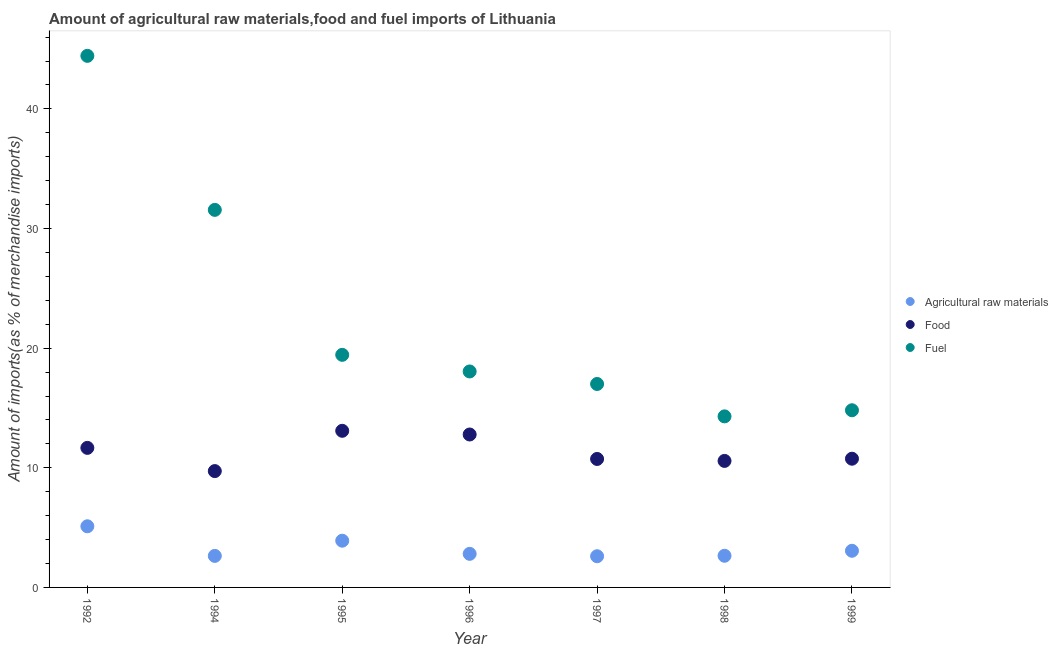How many different coloured dotlines are there?
Provide a succinct answer. 3. Is the number of dotlines equal to the number of legend labels?
Provide a short and direct response. Yes. What is the percentage of raw materials imports in 1998?
Offer a terse response. 2.65. Across all years, what is the maximum percentage of food imports?
Provide a succinct answer. 13.09. Across all years, what is the minimum percentage of food imports?
Provide a succinct answer. 9.72. In which year was the percentage of food imports maximum?
Offer a terse response. 1995. What is the total percentage of food imports in the graph?
Keep it short and to the point. 79.33. What is the difference between the percentage of fuel imports in 1992 and that in 1994?
Make the answer very short. 12.87. What is the difference between the percentage of food imports in 1996 and the percentage of raw materials imports in 1992?
Offer a terse response. 7.67. What is the average percentage of raw materials imports per year?
Give a very brief answer. 3.25. In the year 1996, what is the difference between the percentage of raw materials imports and percentage of food imports?
Provide a short and direct response. -9.98. What is the ratio of the percentage of food imports in 1997 to that in 1999?
Provide a short and direct response. 1. What is the difference between the highest and the second highest percentage of raw materials imports?
Give a very brief answer. 1.2. What is the difference between the highest and the lowest percentage of fuel imports?
Provide a succinct answer. 30.13. In how many years, is the percentage of fuel imports greater than the average percentage of fuel imports taken over all years?
Offer a terse response. 2. Is the sum of the percentage of food imports in 1996 and 1998 greater than the maximum percentage of fuel imports across all years?
Make the answer very short. No. Is it the case that in every year, the sum of the percentage of raw materials imports and percentage of food imports is greater than the percentage of fuel imports?
Your answer should be compact. No. Does the percentage of raw materials imports monotonically increase over the years?
Your answer should be compact. No. Is the percentage of raw materials imports strictly less than the percentage of food imports over the years?
Make the answer very short. Yes. How many dotlines are there?
Your response must be concise. 3. What is the difference between two consecutive major ticks on the Y-axis?
Offer a terse response. 10. Does the graph contain any zero values?
Give a very brief answer. No. Does the graph contain grids?
Your response must be concise. No. How many legend labels are there?
Your answer should be very brief. 3. What is the title of the graph?
Offer a very short reply. Amount of agricultural raw materials,food and fuel imports of Lithuania. What is the label or title of the X-axis?
Give a very brief answer. Year. What is the label or title of the Y-axis?
Offer a terse response. Amount of imports(as % of merchandise imports). What is the Amount of imports(as % of merchandise imports) in Agricultural raw materials in 1992?
Your answer should be very brief. 5.11. What is the Amount of imports(as % of merchandise imports) in Food in 1992?
Keep it short and to the point. 11.66. What is the Amount of imports(as % of merchandise imports) in Fuel in 1992?
Keep it short and to the point. 44.43. What is the Amount of imports(as % of merchandise imports) in Agricultural raw materials in 1994?
Provide a short and direct response. 2.64. What is the Amount of imports(as % of merchandise imports) in Food in 1994?
Keep it short and to the point. 9.72. What is the Amount of imports(as % of merchandise imports) of Fuel in 1994?
Keep it short and to the point. 31.56. What is the Amount of imports(as % of merchandise imports) of Agricultural raw materials in 1995?
Give a very brief answer. 3.91. What is the Amount of imports(as % of merchandise imports) in Food in 1995?
Keep it short and to the point. 13.09. What is the Amount of imports(as % of merchandise imports) of Fuel in 1995?
Provide a short and direct response. 19.44. What is the Amount of imports(as % of merchandise imports) of Agricultural raw materials in 1996?
Offer a terse response. 2.81. What is the Amount of imports(as % of merchandise imports) of Food in 1996?
Make the answer very short. 12.78. What is the Amount of imports(as % of merchandise imports) in Fuel in 1996?
Provide a succinct answer. 18.05. What is the Amount of imports(as % of merchandise imports) in Agricultural raw materials in 1997?
Keep it short and to the point. 2.61. What is the Amount of imports(as % of merchandise imports) of Food in 1997?
Keep it short and to the point. 10.74. What is the Amount of imports(as % of merchandise imports) of Fuel in 1997?
Offer a very short reply. 17. What is the Amount of imports(as % of merchandise imports) of Agricultural raw materials in 1998?
Keep it short and to the point. 2.65. What is the Amount of imports(as % of merchandise imports) in Food in 1998?
Offer a terse response. 10.57. What is the Amount of imports(as % of merchandise imports) of Fuel in 1998?
Give a very brief answer. 14.3. What is the Amount of imports(as % of merchandise imports) of Agricultural raw materials in 1999?
Provide a succinct answer. 3.06. What is the Amount of imports(as % of merchandise imports) of Food in 1999?
Make the answer very short. 10.76. What is the Amount of imports(as % of merchandise imports) in Fuel in 1999?
Offer a terse response. 14.81. Across all years, what is the maximum Amount of imports(as % of merchandise imports) of Agricultural raw materials?
Ensure brevity in your answer.  5.11. Across all years, what is the maximum Amount of imports(as % of merchandise imports) of Food?
Keep it short and to the point. 13.09. Across all years, what is the maximum Amount of imports(as % of merchandise imports) of Fuel?
Your answer should be very brief. 44.43. Across all years, what is the minimum Amount of imports(as % of merchandise imports) in Agricultural raw materials?
Make the answer very short. 2.61. Across all years, what is the minimum Amount of imports(as % of merchandise imports) of Food?
Offer a very short reply. 9.72. Across all years, what is the minimum Amount of imports(as % of merchandise imports) of Fuel?
Keep it short and to the point. 14.3. What is the total Amount of imports(as % of merchandise imports) of Agricultural raw materials in the graph?
Your answer should be very brief. 22.78. What is the total Amount of imports(as % of merchandise imports) of Food in the graph?
Offer a very short reply. 79.33. What is the total Amount of imports(as % of merchandise imports) in Fuel in the graph?
Provide a short and direct response. 159.59. What is the difference between the Amount of imports(as % of merchandise imports) in Agricultural raw materials in 1992 and that in 1994?
Offer a terse response. 2.48. What is the difference between the Amount of imports(as % of merchandise imports) of Food in 1992 and that in 1994?
Ensure brevity in your answer.  1.94. What is the difference between the Amount of imports(as % of merchandise imports) of Fuel in 1992 and that in 1994?
Make the answer very short. 12.87. What is the difference between the Amount of imports(as % of merchandise imports) in Agricultural raw materials in 1992 and that in 1995?
Offer a terse response. 1.2. What is the difference between the Amount of imports(as % of merchandise imports) of Food in 1992 and that in 1995?
Your answer should be compact. -1.43. What is the difference between the Amount of imports(as % of merchandise imports) in Fuel in 1992 and that in 1995?
Provide a short and direct response. 24.99. What is the difference between the Amount of imports(as % of merchandise imports) in Agricultural raw materials in 1992 and that in 1996?
Your response must be concise. 2.3. What is the difference between the Amount of imports(as % of merchandise imports) in Food in 1992 and that in 1996?
Your response must be concise. -1.12. What is the difference between the Amount of imports(as % of merchandise imports) of Fuel in 1992 and that in 1996?
Your answer should be compact. 26.38. What is the difference between the Amount of imports(as % of merchandise imports) in Agricultural raw materials in 1992 and that in 1997?
Your answer should be very brief. 2.5. What is the difference between the Amount of imports(as % of merchandise imports) of Food in 1992 and that in 1997?
Provide a short and direct response. 0.93. What is the difference between the Amount of imports(as % of merchandise imports) of Fuel in 1992 and that in 1997?
Give a very brief answer. 27.43. What is the difference between the Amount of imports(as % of merchandise imports) of Agricultural raw materials in 1992 and that in 1998?
Ensure brevity in your answer.  2.47. What is the difference between the Amount of imports(as % of merchandise imports) in Food in 1992 and that in 1998?
Make the answer very short. 1.09. What is the difference between the Amount of imports(as % of merchandise imports) of Fuel in 1992 and that in 1998?
Ensure brevity in your answer.  30.13. What is the difference between the Amount of imports(as % of merchandise imports) of Agricultural raw materials in 1992 and that in 1999?
Your answer should be very brief. 2.05. What is the difference between the Amount of imports(as % of merchandise imports) of Food in 1992 and that in 1999?
Offer a terse response. 0.91. What is the difference between the Amount of imports(as % of merchandise imports) of Fuel in 1992 and that in 1999?
Give a very brief answer. 29.62. What is the difference between the Amount of imports(as % of merchandise imports) in Agricultural raw materials in 1994 and that in 1995?
Make the answer very short. -1.27. What is the difference between the Amount of imports(as % of merchandise imports) of Food in 1994 and that in 1995?
Offer a terse response. -3.37. What is the difference between the Amount of imports(as % of merchandise imports) of Fuel in 1994 and that in 1995?
Give a very brief answer. 12.12. What is the difference between the Amount of imports(as % of merchandise imports) in Agricultural raw materials in 1994 and that in 1996?
Your response must be concise. -0.17. What is the difference between the Amount of imports(as % of merchandise imports) in Food in 1994 and that in 1996?
Provide a succinct answer. -3.06. What is the difference between the Amount of imports(as % of merchandise imports) of Fuel in 1994 and that in 1996?
Your answer should be compact. 13.51. What is the difference between the Amount of imports(as % of merchandise imports) of Agricultural raw materials in 1994 and that in 1997?
Keep it short and to the point. 0.03. What is the difference between the Amount of imports(as % of merchandise imports) in Food in 1994 and that in 1997?
Your response must be concise. -1.01. What is the difference between the Amount of imports(as % of merchandise imports) of Fuel in 1994 and that in 1997?
Ensure brevity in your answer.  14.55. What is the difference between the Amount of imports(as % of merchandise imports) of Agricultural raw materials in 1994 and that in 1998?
Your answer should be compact. -0.01. What is the difference between the Amount of imports(as % of merchandise imports) of Food in 1994 and that in 1998?
Offer a very short reply. -0.85. What is the difference between the Amount of imports(as % of merchandise imports) of Fuel in 1994 and that in 1998?
Your answer should be compact. 17.26. What is the difference between the Amount of imports(as % of merchandise imports) of Agricultural raw materials in 1994 and that in 1999?
Your answer should be very brief. -0.43. What is the difference between the Amount of imports(as % of merchandise imports) in Food in 1994 and that in 1999?
Offer a very short reply. -1.03. What is the difference between the Amount of imports(as % of merchandise imports) of Fuel in 1994 and that in 1999?
Your answer should be very brief. 16.75. What is the difference between the Amount of imports(as % of merchandise imports) in Agricultural raw materials in 1995 and that in 1996?
Provide a succinct answer. 1.1. What is the difference between the Amount of imports(as % of merchandise imports) of Food in 1995 and that in 1996?
Offer a terse response. 0.31. What is the difference between the Amount of imports(as % of merchandise imports) in Fuel in 1995 and that in 1996?
Your answer should be very brief. 1.39. What is the difference between the Amount of imports(as % of merchandise imports) in Agricultural raw materials in 1995 and that in 1997?
Give a very brief answer. 1.3. What is the difference between the Amount of imports(as % of merchandise imports) of Food in 1995 and that in 1997?
Your response must be concise. 2.35. What is the difference between the Amount of imports(as % of merchandise imports) in Fuel in 1995 and that in 1997?
Offer a very short reply. 2.44. What is the difference between the Amount of imports(as % of merchandise imports) of Agricultural raw materials in 1995 and that in 1998?
Offer a very short reply. 1.26. What is the difference between the Amount of imports(as % of merchandise imports) of Food in 1995 and that in 1998?
Ensure brevity in your answer.  2.52. What is the difference between the Amount of imports(as % of merchandise imports) in Fuel in 1995 and that in 1998?
Provide a short and direct response. 5.14. What is the difference between the Amount of imports(as % of merchandise imports) of Agricultural raw materials in 1995 and that in 1999?
Your answer should be very brief. 0.84. What is the difference between the Amount of imports(as % of merchandise imports) in Food in 1995 and that in 1999?
Give a very brief answer. 2.33. What is the difference between the Amount of imports(as % of merchandise imports) in Fuel in 1995 and that in 1999?
Your answer should be compact. 4.63. What is the difference between the Amount of imports(as % of merchandise imports) in Agricultural raw materials in 1996 and that in 1997?
Your answer should be compact. 0.2. What is the difference between the Amount of imports(as % of merchandise imports) of Food in 1996 and that in 1997?
Ensure brevity in your answer.  2.04. What is the difference between the Amount of imports(as % of merchandise imports) of Fuel in 1996 and that in 1997?
Provide a succinct answer. 1.05. What is the difference between the Amount of imports(as % of merchandise imports) of Agricultural raw materials in 1996 and that in 1998?
Your answer should be very brief. 0.16. What is the difference between the Amount of imports(as % of merchandise imports) of Food in 1996 and that in 1998?
Keep it short and to the point. 2.21. What is the difference between the Amount of imports(as % of merchandise imports) of Fuel in 1996 and that in 1998?
Keep it short and to the point. 3.75. What is the difference between the Amount of imports(as % of merchandise imports) of Agricultural raw materials in 1996 and that in 1999?
Offer a terse response. -0.26. What is the difference between the Amount of imports(as % of merchandise imports) of Food in 1996 and that in 1999?
Provide a succinct answer. 2.02. What is the difference between the Amount of imports(as % of merchandise imports) in Fuel in 1996 and that in 1999?
Offer a terse response. 3.24. What is the difference between the Amount of imports(as % of merchandise imports) in Agricultural raw materials in 1997 and that in 1998?
Keep it short and to the point. -0.04. What is the difference between the Amount of imports(as % of merchandise imports) in Food in 1997 and that in 1998?
Ensure brevity in your answer.  0.16. What is the difference between the Amount of imports(as % of merchandise imports) in Fuel in 1997 and that in 1998?
Keep it short and to the point. 2.71. What is the difference between the Amount of imports(as % of merchandise imports) in Agricultural raw materials in 1997 and that in 1999?
Your response must be concise. -0.46. What is the difference between the Amount of imports(as % of merchandise imports) in Food in 1997 and that in 1999?
Make the answer very short. -0.02. What is the difference between the Amount of imports(as % of merchandise imports) of Fuel in 1997 and that in 1999?
Ensure brevity in your answer.  2.2. What is the difference between the Amount of imports(as % of merchandise imports) of Agricultural raw materials in 1998 and that in 1999?
Make the answer very short. -0.42. What is the difference between the Amount of imports(as % of merchandise imports) of Food in 1998 and that in 1999?
Keep it short and to the point. -0.18. What is the difference between the Amount of imports(as % of merchandise imports) in Fuel in 1998 and that in 1999?
Provide a short and direct response. -0.51. What is the difference between the Amount of imports(as % of merchandise imports) of Agricultural raw materials in 1992 and the Amount of imports(as % of merchandise imports) of Food in 1994?
Make the answer very short. -4.61. What is the difference between the Amount of imports(as % of merchandise imports) of Agricultural raw materials in 1992 and the Amount of imports(as % of merchandise imports) of Fuel in 1994?
Provide a short and direct response. -26.45. What is the difference between the Amount of imports(as % of merchandise imports) in Food in 1992 and the Amount of imports(as % of merchandise imports) in Fuel in 1994?
Make the answer very short. -19.89. What is the difference between the Amount of imports(as % of merchandise imports) in Agricultural raw materials in 1992 and the Amount of imports(as % of merchandise imports) in Food in 1995?
Keep it short and to the point. -7.98. What is the difference between the Amount of imports(as % of merchandise imports) in Agricultural raw materials in 1992 and the Amount of imports(as % of merchandise imports) in Fuel in 1995?
Your answer should be very brief. -14.33. What is the difference between the Amount of imports(as % of merchandise imports) of Food in 1992 and the Amount of imports(as % of merchandise imports) of Fuel in 1995?
Make the answer very short. -7.78. What is the difference between the Amount of imports(as % of merchandise imports) of Agricultural raw materials in 1992 and the Amount of imports(as % of merchandise imports) of Food in 1996?
Offer a very short reply. -7.67. What is the difference between the Amount of imports(as % of merchandise imports) in Agricultural raw materials in 1992 and the Amount of imports(as % of merchandise imports) in Fuel in 1996?
Offer a terse response. -12.94. What is the difference between the Amount of imports(as % of merchandise imports) of Food in 1992 and the Amount of imports(as % of merchandise imports) of Fuel in 1996?
Provide a succinct answer. -6.39. What is the difference between the Amount of imports(as % of merchandise imports) of Agricultural raw materials in 1992 and the Amount of imports(as % of merchandise imports) of Food in 1997?
Ensure brevity in your answer.  -5.63. What is the difference between the Amount of imports(as % of merchandise imports) of Agricultural raw materials in 1992 and the Amount of imports(as % of merchandise imports) of Fuel in 1997?
Make the answer very short. -11.89. What is the difference between the Amount of imports(as % of merchandise imports) in Food in 1992 and the Amount of imports(as % of merchandise imports) in Fuel in 1997?
Offer a terse response. -5.34. What is the difference between the Amount of imports(as % of merchandise imports) of Agricultural raw materials in 1992 and the Amount of imports(as % of merchandise imports) of Food in 1998?
Provide a succinct answer. -5.46. What is the difference between the Amount of imports(as % of merchandise imports) of Agricultural raw materials in 1992 and the Amount of imports(as % of merchandise imports) of Fuel in 1998?
Offer a very short reply. -9.19. What is the difference between the Amount of imports(as % of merchandise imports) of Food in 1992 and the Amount of imports(as % of merchandise imports) of Fuel in 1998?
Keep it short and to the point. -2.63. What is the difference between the Amount of imports(as % of merchandise imports) of Agricultural raw materials in 1992 and the Amount of imports(as % of merchandise imports) of Food in 1999?
Offer a terse response. -5.65. What is the difference between the Amount of imports(as % of merchandise imports) in Agricultural raw materials in 1992 and the Amount of imports(as % of merchandise imports) in Fuel in 1999?
Keep it short and to the point. -9.7. What is the difference between the Amount of imports(as % of merchandise imports) in Food in 1992 and the Amount of imports(as % of merchandise imports) in Fuel in 1999?
Keep it short and to the point. -3.14. What is the difference between the Amount of imports(as % of merchandise imports) in Agricultural raw materials in 1994 and the Amount of imports(as % of merchandise imports) in Food in 1995?
Offer a terse response. -10.45. What is the difference between the Amount of imports(as % of merchandise imports) of Agricultural raw materials in 1994 and the Amount of imports(as % of merchandise imports) of Fuel in 1995?
Give a very brief answer. -16.8. What is the difference between the Amount of imports(as % of merchandise imports) in Food in 1994 and the Amount of imports(as % of merchandise imports) in Fuel in 1995?
Keep it short and to the point. -9.72. What is the difference between the Amount of imports(as % of merchandise imports) of Agricultural raw materials in 1994 and the Amount of imports(as % of merchandise imports) of Food in 1996?
Make the answer very short. -10.15. What is the difference between the Amount of imports(as % of merchandise imports) in Agricultural raw materials in 1994 and the Amount of imports(as % of merchandise imports) in Fuel in 1996?
Your answer should be compact. -15.42. What is the difference between the Amount of imports(as % of merchandise imports) in Food in 1994 and the Amount of imports(as % of merchandise imports) in Fuel in 1996?
Your answer should be compact. -8.33. What is the difference between the Amount of imports(as % of merchandise imports) in Agricultural raw materials in 1994 and the Amount of imports(as % of merchandise imports) in Food in 1997?
Your response must be concise. -8.1. What is the difference between the Amount of imports(as % of merchandise imports) of Agricultural raw materials in 1994 and the Amount of imports(as % of merchandise imports) of Fuel in 1997?
Make the answer very short. -14.37. What is the difference between the Amount of imports(as % of merchandise imports) in Food in 1994 and the Amount of imports(as % of merchandise imports) in Fuel in 1997?
Make the answer very short. -7.28. What is the difference between the Amount of imports(as % of merchandise imports) in Agricultural raw materials in 1994 and the Amount of imports(as % of merchandise imports) in Food in 1998?
Give a very brief answer. -7.94. What is the difference between the Amount of imports(as % of merchandise imports) of Agricultural raw materials in 1994 and the Amount of imports(as % of merchandise imports) of Fuel in 1998?
Your response must be concise. -11.66. What is the difference between the Amount of imports(as % of merchandise imports) of Food in 1994 and the Amount of imports(as % of merchandise imports) of Fuel in 1998?
Give a very brief answer. -4.57. What is the difference between the Amount of imports(as % of merchandise imports) of Agricultural raw materials in 1994 and the Amount of imports(as % of merchandise imports) of Food in 1999?
Offer a very short reply. -8.12. What is the difference between the Amount of imports(as % of merchandise imports) in Agricultural raw materials in 1994 and the Amount of imports(as % of merchandise imports) in Fuel in 1999?
Offer a very short reply. -12.17. What is the difference between the Amount of imports(as % of merchandise imports) in Food in 1994 and the Amount of imports(as % of merchandise imports) in Fuel in 1999?
Provide a succinct answer. -5.08. What is the difference between the Amount of imports(as % of merchandise imports) of Agricultural raw materials in 1995 and the Amount of imports(as % of merchandise imports) of Food in 1996?
Offer a very short reply. -8.88. What is the difference between the Amount of imports(as % of merchandise imports) of Agricultural raw materials in 1995 and the Amount of imports(as % of merchandise imports) of Fuel in 1996?
Provide a short and direct response. -14.15. What is the difference between the Amount of imports(as % of merchandise imports) in Food in 1995 and the Amount of imports(as % of merchandise imports) in Fuel in 1996?
Make the answer very short. -4.96. What is the difference between the Amount of imports(as % of merchandise imports) in Agricultural raw materials in 1995 and the Amount of imports(as % of merchandise imports) in Food in 1997?
Provide a short and direct response. -6.83. What is the difference between the Amount of imports(as % of merchandise imports) of Agricultural raw materials in 1995 and the Amount of imports(as % of merchandise imports) of Fuel in 1997?
Your answer should be compact. -13.1. What is the difference between the Amount of imports(as % of merchandise imports) in Food in 1995 and the Amount of imports(as % of merchandise imports) in Fuel in 1997?
Your response must be concise. -3.91. What is the difference between the Amount of imports(as % of merchandise imports) in Agricultural raw materials in 1995 and the Amount of imports(as % of merchandise imports) in Food in 1998?
Make the answer very short. -6.67. What is the difference between the Amount of imports(as % of merchandise imports) in Agricultural raw materials in 1995 and the Amount of imports(as % of merchandise imports) in Fuel in 1998?
Your response must be concise. -10.39. What is the difference between the Amount of imports(as % of merchandise imports) in Food in 1995 and the Amount of imports(as % of merchandise imports) in Fuel in 1998?
Offer a terse response. -1.21. What is the difference between the Amount of imports(as % of merchandise imports) in Agricultural raw materials in 1995 and the Amount of imports(as % of merchandise imports) in Food in 1999?
Give a very brief answer. -6.85. What is the difference between the Amount of imports(as % of merchandise imports) in Agricultural raw materials in 1995 and the Amount of imports(as % of merchandise imports) in Fuel in 1999?
Provide a short and direct response. -10.9. What is the difference between the Amount of imports(as % of merchandise imports) in Food in 1995 and the Amount of imports(as % of merchandise imports) in Fuel in 1999?
Offer a very short reply. -1.72. What is the difference between the Amount of imports(as % of merchandise imports) of Agricultural raw materials in 1996 and the Amount of imports(as % of merchandise imports) of Food in 1997?
Your answer should be compact. -7.93. What is the difference between the Amount of imports(as % of merchandise imports) of Agricultural raw materials in 1996 and the Amount of imports(as % of merchandise imports) of Fuel in 1997?
Provide a succinct answer. -14.2. What is the difference between the Amount of imports(as % of merchandise imports) of Food in 1996 and the Amount of imports(as % of merchandise imports) of Fuel in 1997?
Make the answer very short. -4.22. What is the difference between the Amount of imports(as % of merchandise imports) of Agricultural raw materials in 1996 and the Amount of imports(as % of merchandise imports) of Food in 1998?
Ensure brevity in your answer.  -7.77. What is the difference between the Amount of imports(as % of merchandise imports) in Agricultural raw materials in 1996 and the Amount of imports(as % of merchandise imports) in Fuel in 1998?
Provide a succinct answer. -11.49. What is the difference between the Amount of imports(as % of merchandise imports) of Food in 1996 and the Amount of imports(as % of merchandise imports) of Fuel in 1998?
Give a very brief answer. -1.51. What is the difference between the Amount of imports(as % of merchandise imports) of Agricultural raw materials in 1996 and the Amount of imports(as % of merchandise imports) of Food in 1999?
Give a very brief answer. -7.95. What is the difference between the Amount of imports(as % of merchandise imports) in Agricultural raw materials in 1996 and the Amount of imports(as % of merchandise imports) in Fuel in 1999?
Your response must be concise. -12. What is the difference between the Amount of imports(as % of merchandise imports) in Food in 1996 and the Amount of imports(as % of merchandise imports) in Fuel in 1999?
Give a very brief answer. -2.03. What is the difference between the Amount of imports(as % of merchandise imports) in Agricultural raw materials in 1997 and the Amount of imports(as % of merchandise imports) in Food in 1998?
Give a very brief answer. -7.97. What is the difference between the Amount of imports(as % of merchandise imports) in Agricultural raw materials in 1997 and the Amount of imports(as % of merchandise imports) in Fuel in 1998?
Your answer should be very brief. -11.69. What is the difference between the Amount of imports(as % of merchandise imports) in Food in 1997 and the Amount of imports(as % of merchandise imports) in Fuel in 1998?
Keep it short and to the point. -3.56. What is the difference between the Amount of imports(as % of merchandise imports) of Agricultural raw materials in 1997 and the Amount of imports(as % of merchandise imports) of Food in 1999?
Keep it short and to the point. -8.15. What is the difference between the Amount of imports(as % of merchandise imports) of Agricultural raw materials in 1997 and the Amount of imports(as % of merchandise imports) of Fuel in 1999?
Your answer should be compact. -12.2. What is the difference between the Amount of imports(as % of merchandise imports) in Food in 1997 and the Amount of imports(as % of merchandise imports) in Fuel in 1999?
Give a very brief answer. -4.07. What is the difference between the Amount of imports(as % of merchandise imports) of Agricultural raw materials in 1998 and the Amount of imports(as % of merchandise imports) of Food in 1999?
Your answer should be compact. -8.11. What is the difference between the Amount of imports(as % of merchandise imports) of Agricultural raw materials in 1998 and the Amount of imports(as % of merchandise imports) of Fuel in 1999?
Your answer should be compact. -12.16. What is the difference between the Amount of imports(as % of merchandise imports) of Food in 1998 and the Amount of imports(as % of merchandise imports) of Fuel in 1999?
Offer a terse response. -4.23. What is the average Amount of imports(as % of merchandise imports) in Agricultural raw materials per year?
Give a very brief answer. 3.25. What is the average Amount of imports(as % of merchandise imports) in Food per year?
Give a very brief answer. 11.33. What is the average Amount of imports(as % of merchandise imports) in Fuel per year?
Your response must be concise. 22.8. In the year 1992, what is the difference between the Amount of imports(as % of merchandise imports) of Agricultural raw materials and Amount of imports(as % of merchandise imports) of Food?
Provide a short and direct response. -6.55. In the year 1992, what is the difference between the Amount of imports(as % of merchandise imports) of Agricultural raw materials and Amount of imports(as % of merchandise imports) of Fuel?
Your response must be concise. -39.32. In the year 1992, what is the difference between the Amount of imports(as % of merchandise imports) of Food and Amount of imports(as % of merchandise imports) of Fuel?
Provide a succinct answer. -32.77. In the year 1994, what is the difference between the Amount of imports(as % of merchandise imports) of Agricultural raw materials and Amount of imports(as % of merchandise imports) of Food?
Keep it short and to the point. -7.09. In the year 1994, what is the difference between the Amount of imports(as % of merchandise imports) in Agricultural raw materials and Amount of imports(as % of merchandise imports) in Fuel?
Provide a short and direct response. -28.92. In the year 1994, what is the difference between the Amount of imports(as % of merchandise imports) of Food and Amount of imports(as % of merchandise imports) of Fuel?
Offer a terse response. -21.83. In the year 1995, what is the difference between the Amount of imports(as % of merchandise imports) of Agricultural raw materials and Amount of imports(as % of merchandise imports) of Food?
Make the answer very short. -9.18. In the year 1995, what is the difference between the Amount of imports(as % of merchandise imports) of Agricultural raw materials and Amount of imports(as % of merchandise imports) of Fuel?
Provide a short and direct response. -15.53. In the year 1995, what is the difference between the Amount of imports(as % of merchandise imports) in Food and Amount of imports(as % of merchandise imports) in Fuel?
Offer a terse response. -6.35. In the year 1996, what is the difference between the Amount of imports(as % of merchandise imports) of Agricultural raw materials and Amount of imports(as % of merchandise imports) of Food?
Provide a short and direct response. -9.98. In the year 1996, what is the difference between the Amount of imports(as % of merchandise imports) in Agricultural raw materials and Amount of imports(as % of merchandise imports) in Fuel?
Provide a short and direct response. -15.24. In the year 1996, what is the difference between the Amount of imports(as % of merchandise imports) of Food and Amount of imports(as % of merchandise imports) of Fuel?
Provide a short and direct response. -5.27. In the year 1997, what is the difference between the Amount of imports(as % of merchandise imports) in Agricultural raw materials and Amount of imports(as % of merchandise imports) in Food?
Give a very brief answer. -8.13. In the year 1997, what is the difference between the Amount of imports(as % of merchandise imports) of Agricultural raw materials and Amount of imports(as % of merchandise imports) of Fuel?
Provide a succinct answer. -14.4. In the year 1997, what is the difference between the Amount of imports(as % of merchandise imports) of Food and Amount of imports(as % of merchandise imports) of Fuel?
Provide a succinct answer. -6.27. In the year 1998, what is the difference between the Amount of imports(as % of merchandise imports) of Agricultural raw materials and Amount of imports(as % of merchandise imports) of Food?
Offer a terse response. -7.93. In the year 1998, what is the difference between the Amount of imports(as % of merchandise imports) in Agricultural raw materials and Amount of imports(as % of merchandise imports) in Fuel?
Offer a very short reply. -11.65. In the year 1998, what is the difference between the Amount of imports(as % of merchandise imports) of Food and Amount of imports(as % of merchandise imports) of Fuel?
Provide a succinct answer. -3.72. In the year 1999, what is the difference between the Amount of imports(as % of merchandise imports) of Agricultural raw materials and Amount of imports(as % of merchandise imports) of Food?
Your answer should be very brief. -7.69. In the year 1999, what is the difference between the Amount of imports(as % of merchandise imports) of Agricultural raw materials and Amount of imports(as % of merchandise imports) of Fuel?
Keep it short and to the point. -11.74. In the year 1999, what is the difference between the Amount of imports(as % of merchandise imports) in Food and Amount of imports(as % of merchandise imports) in Fuel?
Offer a terse response. -4.05. What is the ratio of the Amount of imports(as % of merchandise imports) of Agricultural raw materials in 1992 to that in 1994?
Keep it short and to the point. 1.94. What is the ratio of the Amount of imports(as % of merchandise imports) of Food in 1992 to that in 1994?
Offer a terse response. 1.2. What is the ratio of the Amount of imports(as % of merchandise imports) in Fuel in 1992 to that in 1994?
Your response must be concise. 1.41. What is the ratio of the Amount of imports(as % of merchandise imports) in Agricultural raw materials in 1992 to that in 1995?
Your answer should be compact. 1.31. What is the ratio of the Amount of imports(as % of merchandise imports) of Food in 1992 to that in 1995?
Give a very brief answer. 0.89. What is the ratio of the Amount of imports(as % of merchandise imports) in Fuel in 1992 to that in 1995?
Your answer should be compact. 2.29. What is the ratio of the Amount of imports(as % of merchandise imports) in Agricultural raw materials in 1992 to that in 1996?
Keep it short and to the point. 1.82. What is the ratio of the Amount of imports(as % of merchandise imports) of Food in 1992 to that in 1996?
Make the answer very short. 0.91. What is the ratio of the Amount of imports(as % of merchandise imports) of Fuel in 1992 to that in 1996?
Your answer should be very brief. 2.46. What is the ratio of the Amount of imports(as % of merchandise imports) in Agricultural raw materials in 1992 to that in 1997?
Your answer should be very brief. 1.96. What is the ratio of the Amount of imports(as % of merchandise imports) of Food in 1992 to that in 1997?
Offer a terse response. 1.09. What is the ratio of the Amount of imports(as % of merchandise imports) of Fuel in 1992 to that in 1997?
Provide a succinct answer. 2.61. What is the ratio of the Amount of imports(as % of merchandise imports) of Agricultural raw materials in 1992 to that in 1998?
Your answer should be very brief. 1.93. What is the ratio of the Amount of imports(as % of merchandise imports) of Food in 1992 to that in 1998?
Offer a very short reply. 1.1. What is the ratio of the Amount of imports(as % of merchandise imports) in Fuel in 1992 to that in 1998?
Offer a very short reply. 3.11. What is the ratio of the Amount of imports(as % of merchandise imports) in Agricultural raw materials in 1992 to that in 1999?
Your answer should be compact. 1.67. What is the ratio of the Amount of imports(as % of merchandise imports) of Food in 1992 to that in 1999?
Your answer should be very brief. 1.08. What is the ratio of the Amount of imports(as % of merchandise imports) in Fuel in 1992 to that in 1999?
Provide a short and direct response. 3. What is the ratio of the Amount of imports(as % of merchandise imports) in Agricultural raw materials in 1994 to that in 1995?
Give a very brief answer. 0.67. What is the ratio of the Amount of imports(as % of merchandise imports) in Food in 1994 to that in 1995?
Offer a very short reply. 0.74. What is the ratio of the Amount of imports(as % of merchandise imports) of Fuel in 1994 to that in 1995?
Your response must be concise. 1.62. What is the ratio of the Amount of imports(as % of merchandise imports) in Agricultural raw materials in 1994 to that in 1996?
Offer a terse response. 0.94. What is the ratio of the Amount of imports(as % of merchandise imports) in Food in 1994 to that in 1996?
Make the answer very short. 0.76. What is the ratio of the Amount of imports(as % of merchandise imports) in Fuel in 1994 to that in 1996?
Keep it short and to the point. 1.75. What is the ratio of the Amount of imports(as % of merchandise imports) in Food in 1994 to that in 1997?
Keep it short and to the point. 0.91. What is the ratio of the Amount of imports(as % of merchandise imports) in Fuel in 1994 to that in 1997?
Ensure brevity in your answer.  1.86. What is the ratio of the Amount of imports(as % of merchandise imports) in Food in 1994 to that in 1998?
Keep it short and to the point. 0.92. What is the ratio of the Amount of imports(as % of merchandise imports) in Fuel in 1994 to that in 1998?
Offer a very short reply. 2.21. What is the ratio of the Amount of imports(as % of merchandise imports) of Agricultural raw materials in 1994 to that in 1999?
Make the answer very short. 0.86. What is the ratio of the Amount of imports(as % of merchandise imports) in Food in 1994 to that in 1999?
Offer a terse response. 0.9. What is the ratio of the Amount of imports(as % of merchandise imports) of Fuel in 1994 to that in 1999?
Your response must be concise. 2.13. What is the ratio of the Amount of imports(as % of merchandise imports) in Agricultural raw materials in 1995 to that in 1996?
Offer a very short reply. 1.39. What is the ratio of the Amount of imports(as % of merchandise imports) in Food in 1995 to that in 1996?
Your answer should be compact. 1.02. What is the ratio of the Amount of imports(as % of merchandise imports) of Agricultural raw materials in 1995 to that in 1997?
Keep it short and to the point. 1.5. What is the ratio of the Amount of imports(as % of merchandise imports) in Food in 1995 to that in 1997?
Provide a short and direct response. 1.22. What is the ratio of the Amount of imports(as % of merchandise imports) of Fuel in 1995 to that in 1997?
Make the answer very short. 1.14. What is the ratio of the Amount of imports(as % of merchandise imports) of Agricultural raw materials in 1995 to that in 1998?
Your response must be concise. 1.48. What is the ratio of the Amount of imports(as % of merchandise imports) of Food in 1995 to that in 1998?
Your response must be concise. 1.24. What is the ratio of the Amount of imports(as % of merchandise imports) of Fuel in 1995 to that in 1998?
Offer a terse response. 1.36. What is the ratio of the Amount of imports(as % of merchandise imports) of Agricultural raw materials in 1995 to that in 1999?
Keep it short and to the point. 1.28. What is the ratio of the Amount of imports(as % of merchandise imports) of Food in 1995 to that in 1999?
Your answer should be very brief. 1.22. What is the ratio of the Amount of imports(as % of merchandise imports) in Fuel in 1995 to that in 1999?
Provide a succinct answer. 1.31. What is the ratio of the Amount of imports(as % of merchandise imports) of Agricultural raw materials in 1996 to that in 1997?
Provide a short and direct response. 1.08. What is the ratio of the Amount of imports(as % of merchandise imports) of Food in 1996 to that in 1997?
Ensure brevity in your answer.  1.19. What is the ratio of the Amount of imports(as % of merchandise imports) of Fuel in 1996 to that in 1997?
Your answer should be very brief. 1.06. What is the ratio of the Amount of imports(as % of merchandise imports) in Agricultural raw materials in 1996 to that in 1998?
Provide a succinct answer. 1.06. What is the ratio of the Amount of imports(as % of merchandise imports) of Food in 1996 to that in 1998?
Keep it short and to the point. 1.21. What is the ratio of the Amount of imports(as % of merchandise imports) in Fuel in 1996 to that in 1998?
Ensure brevity in your answer.  1.26. What is the ratio of the Amount of imports(as % of merchandise imports) in Agricultural raw materials in 1996 to that in 1999?
Ensure brevity in your answer.  0.92. What is the ratio of the Amount of imports(as % of merchandise imports) in Food in 1996 to that in 1999?
Ensure brevity in your answer.  1.19. What is the ratio of the Amount of imports(as % of merchandise imports) in Fuel in 1996 to that in 1999?
Your answer should be very brief. 1.22. What is the ratio of the Amount of imports(as % of merchandise imports) in Agricultural raw materials in 1997 to that in 1998?
Ensure brevity in your answer.  0.99. What is the ratio of the Amount of imports(as % of merchandise imports) in Food in 1997 to that in 1998?
Keep it short and to the point. 1.02. What is the ratio of the Amount of imports(as % of merchandise imports) of Fuel in 1997 to that in 1998?
Your answer should be very brief. 1.19. What is the ratio of the Amount of imports(as % of merchandise imports) of Agricultural raw materials in 1997 to that in 1999?
Provide a short and direct response. 0.85. What is the ratio of the Amount of imports(as % of merchandise imports) in Food in 1997 to that in 1999?
Your answer should be compact. 1. What is the ratio of the Amount of imports(as % of merchandise imports) in Fuel in 1997 to that in 1999?
Offer a very short reply. 1.15. What is the ratio of the Amount of imports(as % of merchandise imports) of Agricultural raw materials in 1998 to that in 1999?
Provide a short and direct response. 0.86. What is the ratio of the Amount of imports(as % of merchandise imports) of Food in 1998 to that in 1999?
Offer a very short reply. 0.98. What is the ratio of the Amount of imports(as % of merchandise imports) of Fuel in 1998 to that in 1999?
Your answer should be very brief. 0.97. What is the difference between the highest and the second highest Amount of imports(as % of merchandise imports) of Agricultural raw materials?
Make the answer very short. 1.2. What is the difference between the highest and the second highest Amount of imports(as % of merchandise imports) in Food?
Give a very brief answer. 0.31. What is the difference between the highest and the second highest Amount of imports(as % of merchandise imports) of Fuel?
Give a very brief answer. 12.87. What is the difference between the highest and the lowest Amount of imports(as % of merchandise imports) of Agricultural raw materials?
Ensure brevity in your answer.  2.5. What is the difference between the highest and the lowest Amount of imports(as % of merchandise imports) in Food?
Keep it short and to the point. 3.37. What is the difference between the highest and the lowest Amount of imports(as % of merchandise imports) in Fuel?
Make the answer very short. 30.13. 